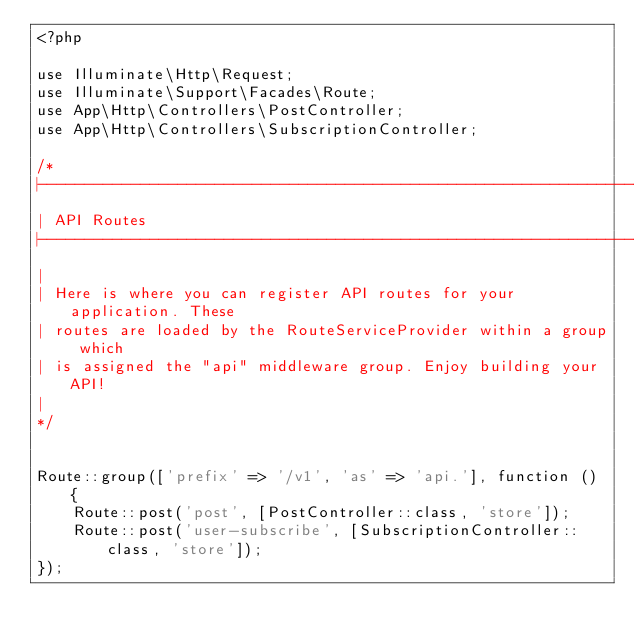Convert code to text. <code><loc_0><loc_0><loc_500><loc_500><_PHP_><?php

use Illuminate\Http\Request;
use Illuminate\Support\Facades\Route;
use App\Http\Controllers\PostController;
use App\Http\Controllers\SubscriptionController;

/*
|--------------------------------------------------------------------------
| API Routes
|--------------------------------------------------------------------------
|
| Here is where you can register API routes for your application. These
| routes are loaded by the RouteServiceProvider within a group which
| is assigned the "api" middleware group. Enjoy building your API!
|
*/


Route::group(['prefix' => '/v1', 'as' => 'api.'], function () {
    Route::post('post', [PostController::class, 'store']);
    Route::post('user-subscribe', [SubscriptionController::class, 'store']);
});
</code> 